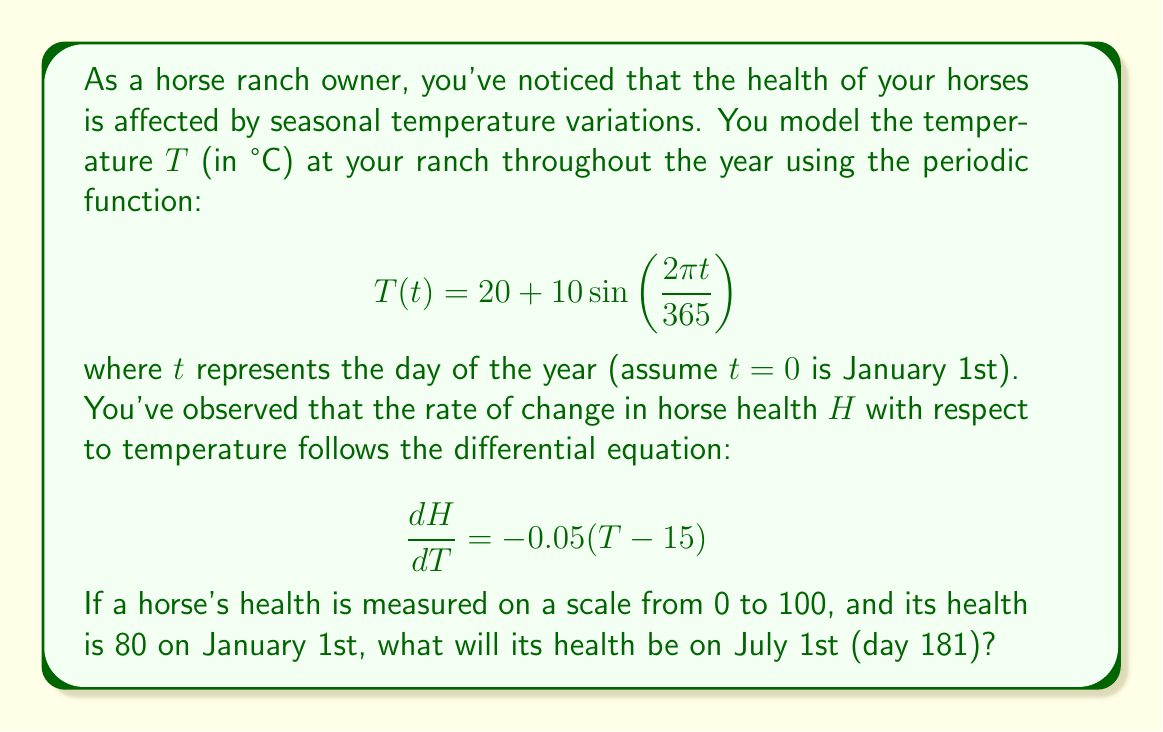Could you help me with this problem? Let's approach this step-by-step:

1) First, we need to find the temperature on July 1st (day 181):
   $$T(181) = 20 + 10\sin\left(\frac{2\pi \cdot 181}{365}\right) \approx 29.84°C$$

2) Now, we need to integrate the differential equation to find the change in health from January 1st to July 1st:
   $$\frac{dH}{dT} = -0.05(T-15)$$
   $$dH = -0.05(T-15)dT$$

3) To integrate this, we need to express $T$ in terms of $t$:
   $$dH = -0.05\left(20 + 10\sin\left(\frac{2\pi t}{365}\right) - 15\right)dt$$
   $$dH = -0.05\left(5 + 10\sin\left(\frac{2\pi t}{365}\right)\right)dt$$

4) Integrating from $t=0$ to $t=181$:
   $$\Delta H = -0.05 \int_0^{181} \left(5 + 10\sin\left(\frac{2\pi t}{365}\right)\right)dt$$
   $$= -0.05 \left[5t - \frac{365}{2\pi} \cdot 10\cos\left(\frac{2\pi t}{365}\right)\right]_0^{181}$$

5) Evaluating the integral:
   $$\Delta H = -0.05 \left(905 - \frac{3650}{2\pi} \cos\left(\frac{2\pi \cdot 181}{365}\right) + \frac{3650}{2\pi}\right)$$
   $$\approx -8.98$$

6) The horse's health started at 80 on January 1st, so on July 1st it will be:
   $$80 - 8.98 \approx 71.02$$
Answer: The horse's health on July 1st will be approximately 71.02 on a scale from 0 to 100. 